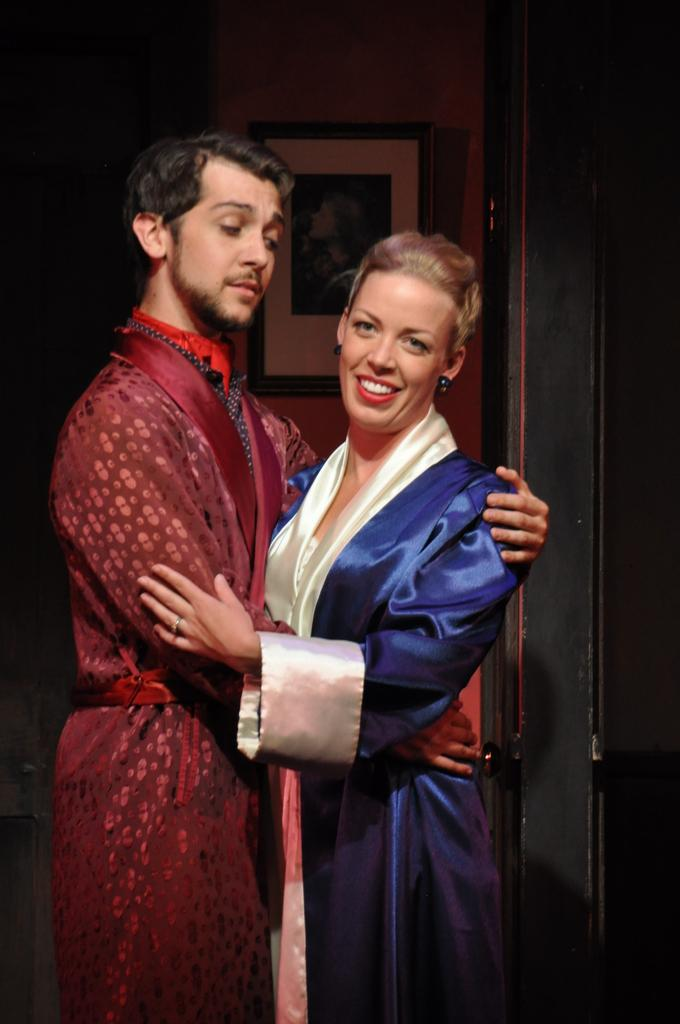How many people are in the image? There are two people in the image. What are the two people doing in the image? The two people are standing and hugging each other. What can be seen in the background of the image? There is a frame attached to a wall in the background of the image. How many bikes are parked next to the people in the image? There are no bikes present in the image. What verse is being recited by the people in the image? There is no indication in the image that the people are reciting a verse. 